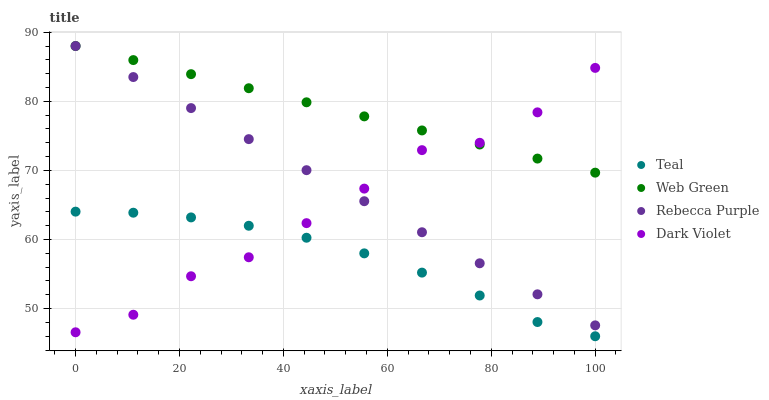Does Teal have the minimum area under the curve?
Answer yes or no. Yes. Does Web Green have the maximum area under the curve?
Answer yes or no. Yes. Does Web Green have the minimum area under the curve?
Answer yes or no. No. Does Teal have the maximum area under the curve?
Answer yes or no. No. Is Rebecca Purple the smoothest?
Answer yes or no. Yes. Is Dark Violet the roughest?
Answer yes or no. Yes. Is Web Green the smoothest?
Answer yes or no. No. Is Web Green the roughest?
Answer yes or no. No. Does Teal have the lowest value?
Answer yes or no. Yes. Does Web Green have the lowest value?
Answer yes or no. No. Does Rebecca Purple have the highest value?
Answer yes or no. Yes. Does Teal have the highest value?
Answer yes or no. No. Is Teal less than Rebecca Purple?
Answer yes or no. Yes. Is Rebecca Purple greater than Teal?
Answer yes or no. Yes. Does Web Green intersect Dark Violet?
Answer yes or no. Yes. Is Web Green less than Dark Violet?
Answer yes or no. No. Is Web Green greater than Dark Violet?
Answer yes or no. No. Does Teal intersect Rebecca Purple?
Answer yes or no. No. 